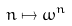<formula> <loc_0><loc_0><loc_500><loc_500>n \mapsto \omega ^ { n }</formula> 